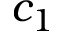<formula> <loc_0><loc_0><loc_500><loc_500>c _ { 1 }</formula> 